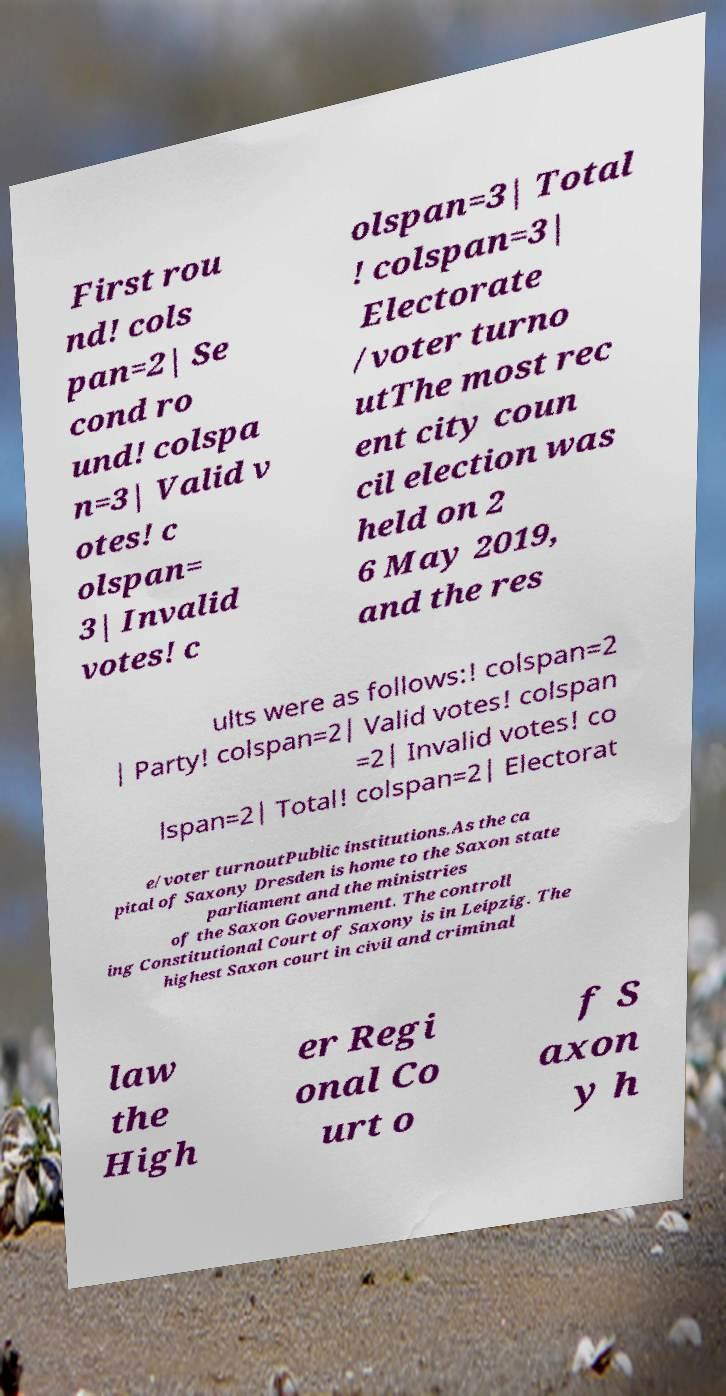Could you assist in decoding the text presented in this image and type it out clearly? First rou nd! cols pan=2| Se cond ro und! colspa n=3| Valid v otes! c olspan= 3| Invalid votes! c olspan=3| Total ! colspan=3| Electorate /voter turno utThe most rec ent city coun cil election was held on 2 6 May 2019, and the res ults were as follows:! colspan=2 | Party! colspan=2| Valid votes! colspan =2| Invalid votes! co lspan=2| Total! colspan=2| Electorat e/voter turnoutPublic institutions.As the ca pital of Saxony Dresden is home to the Saxon state parliament and the ministries of the Saxon Government. The controll ing Constitutional Court of Saxony is in Leipzig. The highest Saxon court in civil and criminal law the High er Regi onal Co urt o f S axon y h 